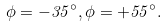<formula> <loc_0><loc_0><loc_500><loc_500>\phi = - 3 5 ^ { \circ } , \phi = + 5 5 ^ { \circ } .</formula> 